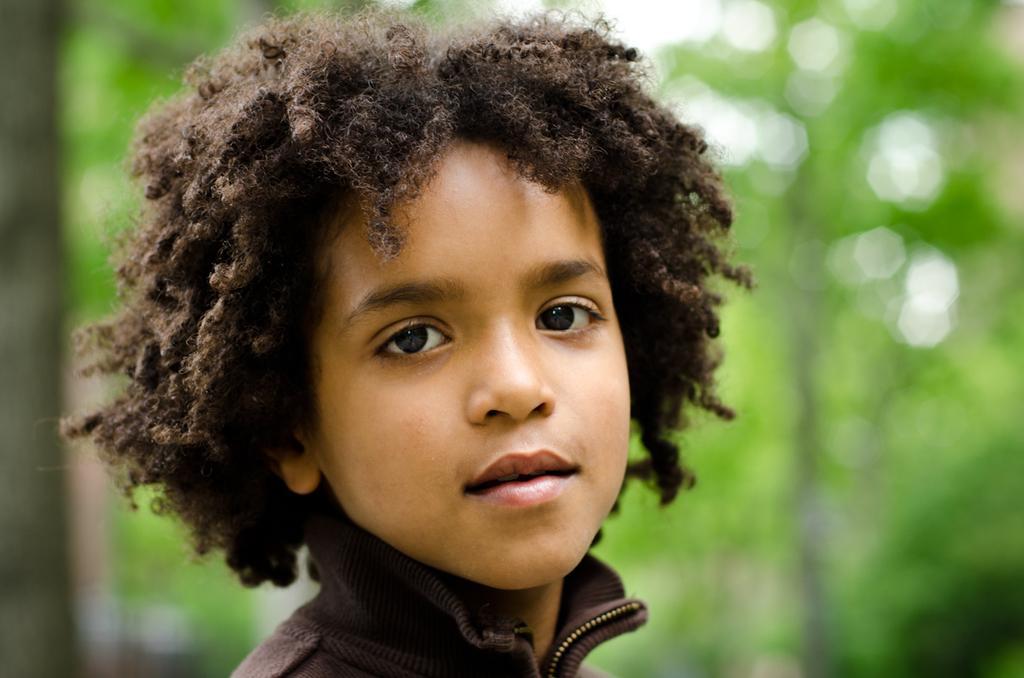Can you describe this image briefly? A boy is looking at his side, he wore brown color coat. 